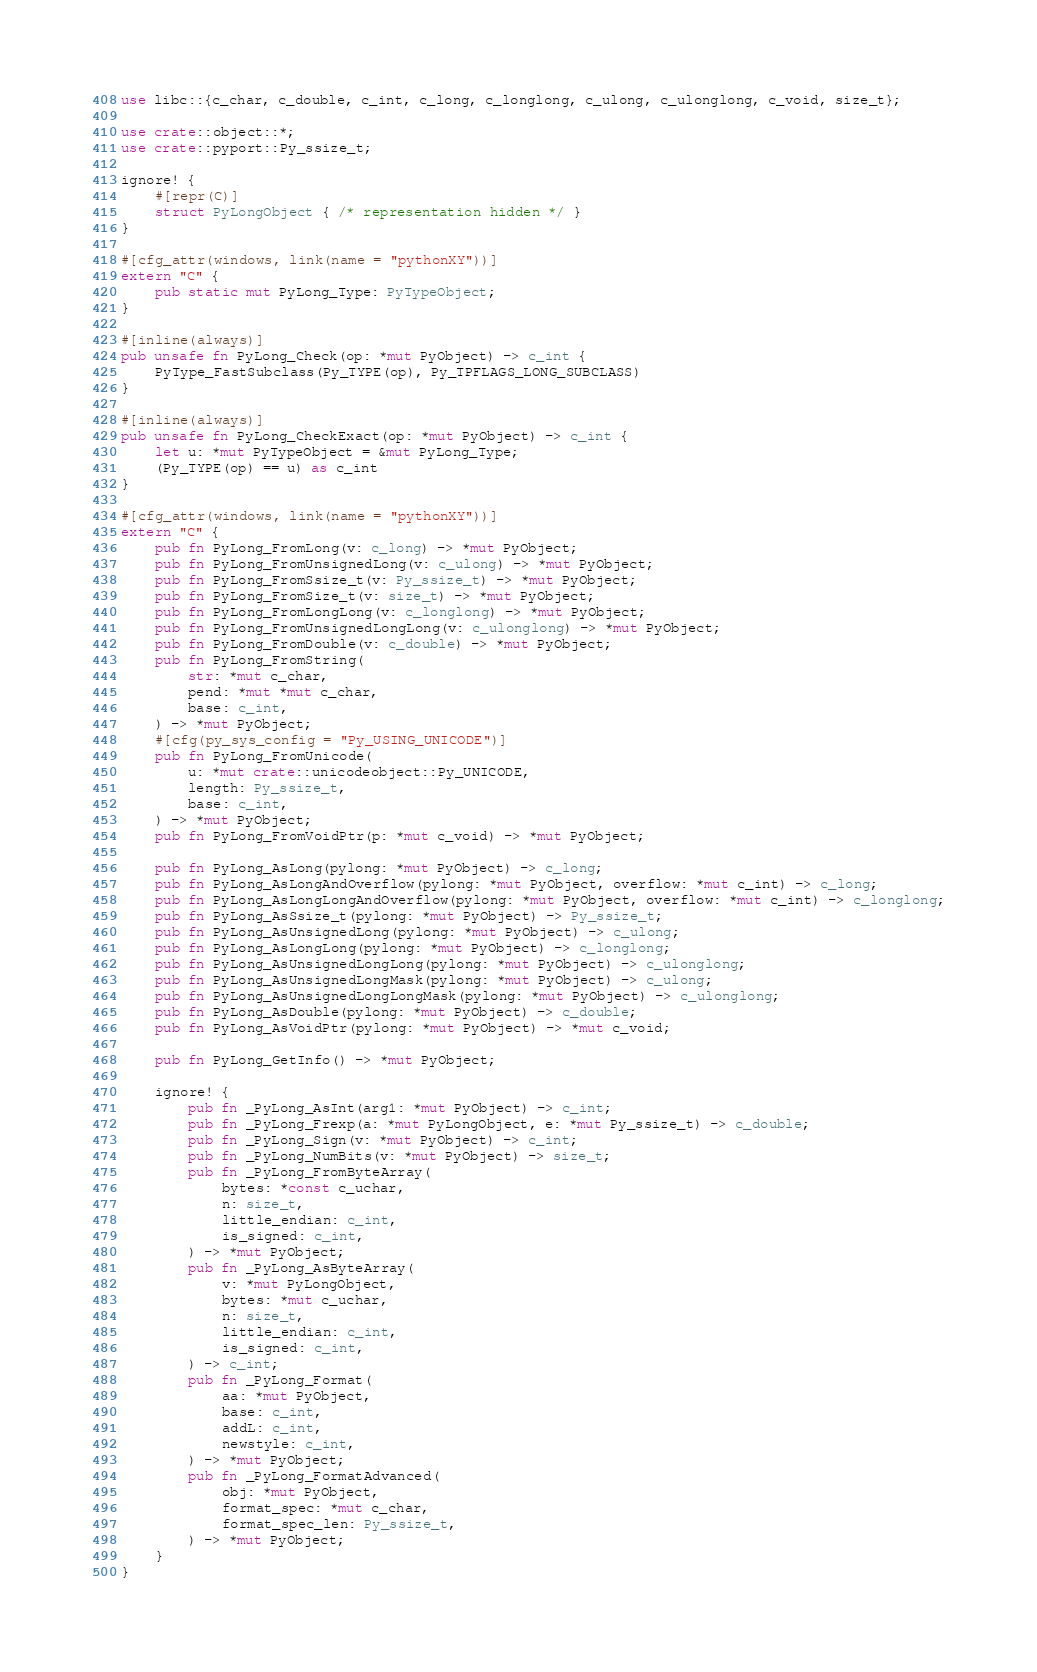<code> <loc_0><loc_0><loc_500><loc_500><_Rust_>use libc::{c_char, c_double, c_int, c_long, c_longlong, c_ulong, c_ulonglong, c_void, size_t};

use crate::object::*;
use crate::pyport::Py_ssize_t;

ignore! {
    #[repr(C)]
    struct PyLongObject { /* representation hidden */ }
}

#[cfg_attr(windows, link(name = "pythonXY"))]
extern "C" {
    pub static mut PyLong_Type: PyTypeObject;
}

#[inline(always)]
pub unsafe fn PyLong_Check(op: *mut PyObject) -> c_int {
    PyType_FastSubclass(Py_TYPE(op), Py_TPFLAGS_LONG_SUBCLASS)
}

#[inline(always)]
pub unsafe fn PyLong_CheckExact(op: *mut PyObject) -> c_int {
    let u: *mut PyTypeObject = &mut PyLong_Type;
    (Py_TYPE(op) == u) as c_int
}

#[cfg_attr(windows, link(name = "pythonXY"))]
extern "C" {
    pub fn PyLong_FromLong(v: c_long) -> *mut PyObject;
    pub fn PyLong_FromUnsignedLong(v: c_ulong) -> *mut PyObject;
    pub fn PyLong_FromSsize_t(v: Py_ssize_t) -> *mut PyObject;
    pub fn PyLong_FromSize_t(v: size_t) -> *mut PyObject;
    pub fn PyLong_FromLongLong(v: c_longlong) -> *mut PyObject;
    pub fn PyLong_FromUnsignedLongLong(v: c_ulonglong) -> *mut PyObject;
    pub fn PyLong_FromDouble(v: c_double) -> *mut PyObject;
    pub fn PyLong_FromString(
        str: *mut c_char,
        pend: *mut *mut c_char,
        base: c_int,
    ) -> *mut PyObject;
    #[cfg(py_sys_config = "Py_USING_UNICODE")]
    pub fn PyLong_FromUnicode(
        u: *mut crate::unicodeobject::Py_UNICODE,
        length: Py_ssize_t,
        base: c_int,
    ) -> *mut PyObject;
    pub fn PyLong_FromVoidPtr(p: *mut c_void) -> *mut PyObject;

    pub fn PyLong_AsLong(pylong: *mut PyObject) -> c_long;
    pub fn PyLong_AsLongAndOverflow(pylong: *mut PyObject, overflow: *mut c_int) -> c_long;
    pub fn PyLong_AsLongLongAndOverflow(pylong: *mut PyObject, overflow: *mut c_int) -> c_longlong;
    pub fn PyLong_AsSsize_t(pylong: *mut PyObject) -> Py_ssize_t;
    pub fn PyLong_AsUnsignedLong(pylong: *mut PyObject) -> c_ulong;
    pub fn PyLong_AsLongLong(pylong: *mut PyObject) -> c_longlong;
    pub fn PyLong_AsUnsignedLongLong(pylong: *mut PyObject) -> c_ulonglong;
    pub fn PyLong_AsUnsignedLongMask(pylong: *mut PyObject) -> c_ulong;
    pub fn PyLong_AsUnsignedLongLongMask(pylong: *mut PyObject) -> c_ulonglong;
    pub fn PyLong_AsDouble(pylong: *mut PyObject) -> c_double;
    pub fn PyLong_AsVoidPtr(pylong: *mut PyObject) -> *mut c_void;

    pub fn PyLong_GetInfo() -> *mut PyObject;

    ignore! {
        pub fn _PyLong_AsInt(arg1: *mut PyObject) -> c_int;
        pub fn _PyLong_Frexp(a: *mut PyLongObject, e: *mut Py_ssize_t) -> c_double;
        pub fn _PyLong_Sign(v: *mut PyObject) -> c_int;
        pub fn _PyLong_NumBits(v: *mut PyObject) -> size_t;
        pub fn _PyLong_FromByteArray(
            bytes: *const c_uchar,
            n: size_t,
            little_endian: c_int,
            is_signed: c_int,
        ) -> *mut PyObject;
        pub fn _PyLong_AsByteArray(
            v: *mut PyLongObject,
            bytes: *mut c_uchar,
            n: size_t,
            little_endian: c_int,
            is_signed: c_int,
        ) -> c_int;
        pub fn _PyLong_Format(
            aa: *mut PyObject,
            base: c_int,
            addL: c_int,
            newstyle: c_int,
        ) -> *mut PyObject;
        pub fn _PyLong_FormatAdvanced(
            obj: *mut PyObject,
            format_spec: *mut c_char,
            format_spec_len: Py_ssize_t,
        ) -> *mut PyObject;
    }
}
</code> 